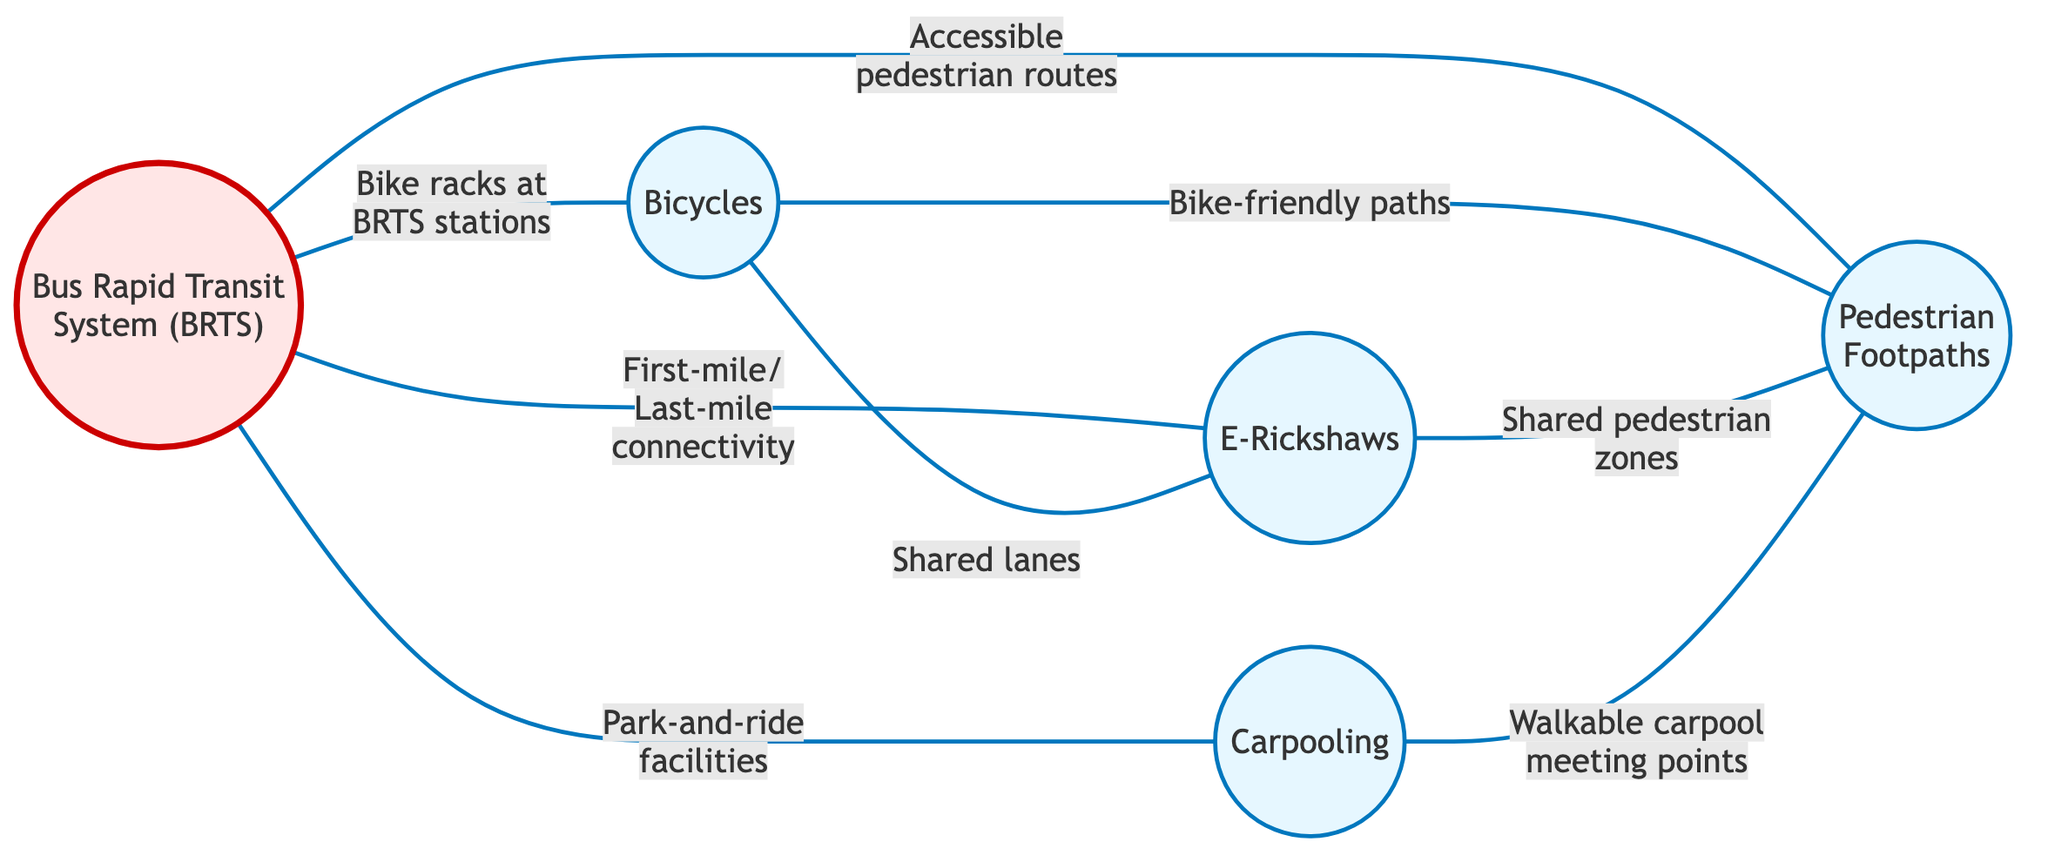What is the total number of nodes in the graph? The graph contains nodes for BRTS, Bicycles, E-Rickshaws, Carpooling, and Footpaths. Counting these nodes gives a total of 5.
Answer: 5 How many edges connect to the BRTS node? Looking at the edges connected to the BRTS node, there are 4 edges: one to Bicycles, one to E-Rickshaws, one to Carpooling, and one to Footpaths. Therefore, there are 4 edges connecting to BRTS.
Answer: 4 What is the relationship between Bicycles and E-Rickshaws? The edge connects Bicycles and E-Rickshaws with the label "Shared lanes," indicating there is a shared connection for these two modes of transportation.
Answer: Shared lanes Which mode of green transportation has the most connections? By evaluating the edges, BRTS connects to four other nodes, while others connect to fewer. Hence, BRTS has the most connections.
Answer: BRTS How are E-Rickshaws linked to Footpaths? An edge connects E-Rickshaws to Footpaths, labeled "Shared pedestrian zones," indicating a direct relationship focusing on pedestrian integration.
Answer: Shared pedestrian zones What type of transportation is associated with bike racks? The edge labeled "Bike racks at BRTS stations" connects the BRTS to Bicycles, indicating that Bicycles have bike racks associated with the BRTS.
Answer: Bicycles What common route type do Carpooling and Footpaths share? Both Carpooling and Footpaths are connected by an edge labeled "Walkable carpool meeting points," suggesting that the locations for carpooling are designed to be pedestrian-friendly.
Answer: Walkable carpool meeting points Which mode of transportation acts as a first-mile/last-mile solution? The edge connecting BRTS and E-Rickshaws is labeled "First-mile/Last-mile connectivity," making E-Rickshaws act as a first-mile/last-mile solution connected to BRTS.
Answer: E-Rickshaws What is the overall theme of the relationships represented in this graph? The edges among the nodes illustrate an integration of different green transportation modes designed to promote accessibility and sustainability within Surat.
Answer: Integration of green transportation 